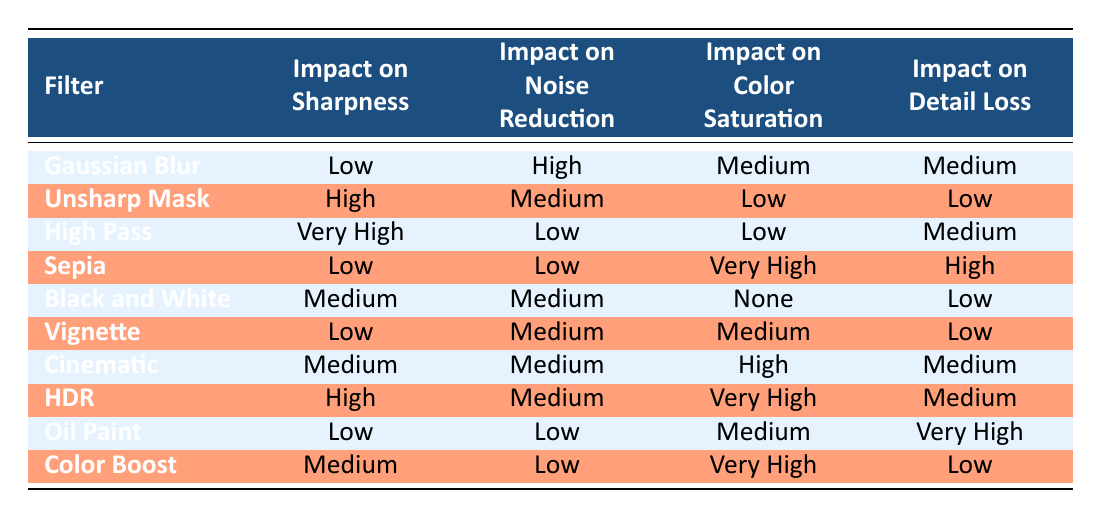What filter has the highest impact on sharpness? The table shows that the "High Pass" filter has a "Very High" impact on sharpness, which is higher than any other filter listed.
Answer: High Pass Which filter has the lowest impact on color saturation? According to the table, the "Black and White" filter has an impact of "None" on color saturation, making it the lowest among all filters.
Answer: Black and White Is the impact on noise reduction high for the Sepia filter? The table indicates that the "Sepia" filter has an impact on noise reduction categorized as "Low," so it is not high.
Answer: No What is the average impact on detail loss for the filters? The impacts on detail loss can be assigned numerical values: High (3), Medium (2), Low (1), and None (0). The data points are: Medium (1), Low (4), High (2), Very High (3). The total is (2 + 1 + 3 + 1 + 2 + 1 + 2 + 2 + 1 + 3) = 18 and there are 10 filters, so the average is 18/10 = 1.8.
Answer: 1.8 Which filters have a medium impact on sharpness? The "Black and White," "Cinematic," and "Color Boost" filters all have a medium impact on sharpness according to the table.
Answer: Black and White, Cinematic, Color Boost What is the filter with the highest impact on color saturation? The "Sepia" filter has the highest impact on color saturation classified as "Very High" in the table.
Answer: Sepia Does any filter completely reduce noise? Upon reviewing the information, no filter shows a "Very High" impact on noise reduction; the highest seen is "High" for the "Gaussian Blur" filter.
Answer: No Which filter keeps detail loss to a minimum? The "Unsharp Mask" and "Black and White" filters both showcase a low impact on detail loss, indicating they preserve details better than others.
Answer: Unsharp Mask, Black and White 